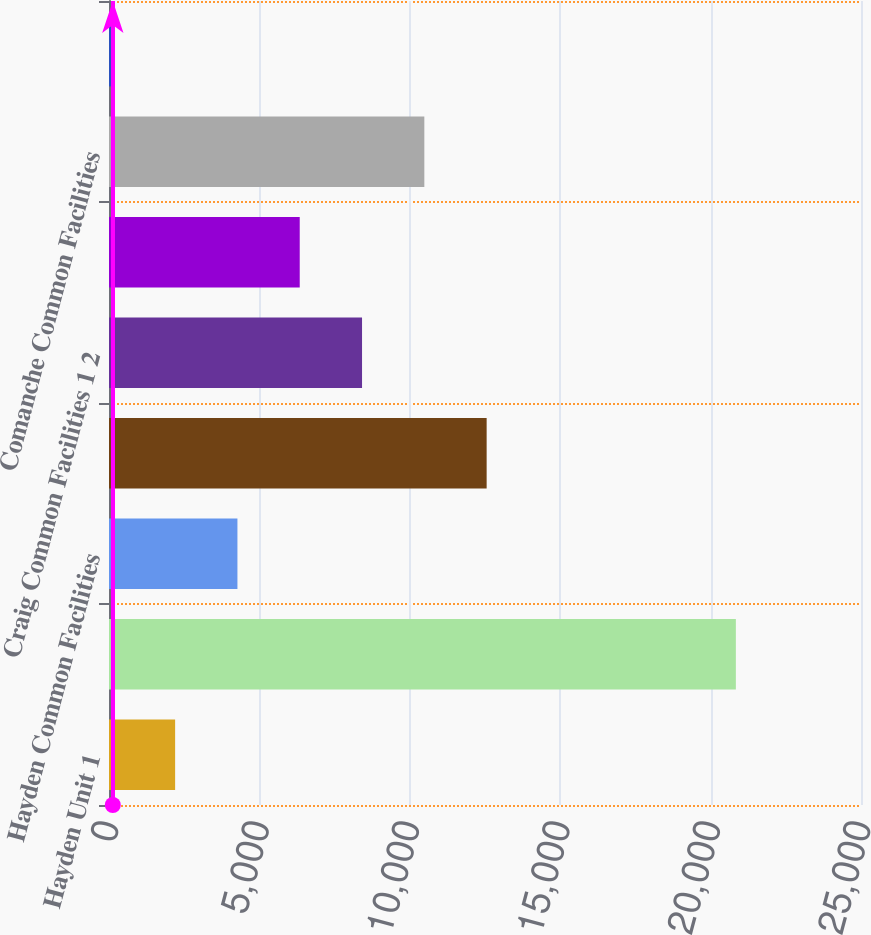Convert chart to OTSL. <chart><loc_0><loc_0><loc_500><loc_500><bar_chart><fcel>Hayden Unit 1<fcel>Hayden Unit 2<fcel>Hayden Common Facilities<fcel>Craig Units 1 and 2<fcel>Craig Common Facilities 1 2<fcel>Comanche Unit 3<fcel>Comanche Common Facilities<fcel>Gas Transportation Compressor<nl><fcel>2198.3<fcel>20840<fcel>4269.6<fcel>12554.8<fcel>8412.2<fcel>6340.9<fcel>10483.5<fcel>127<nl></chart> 